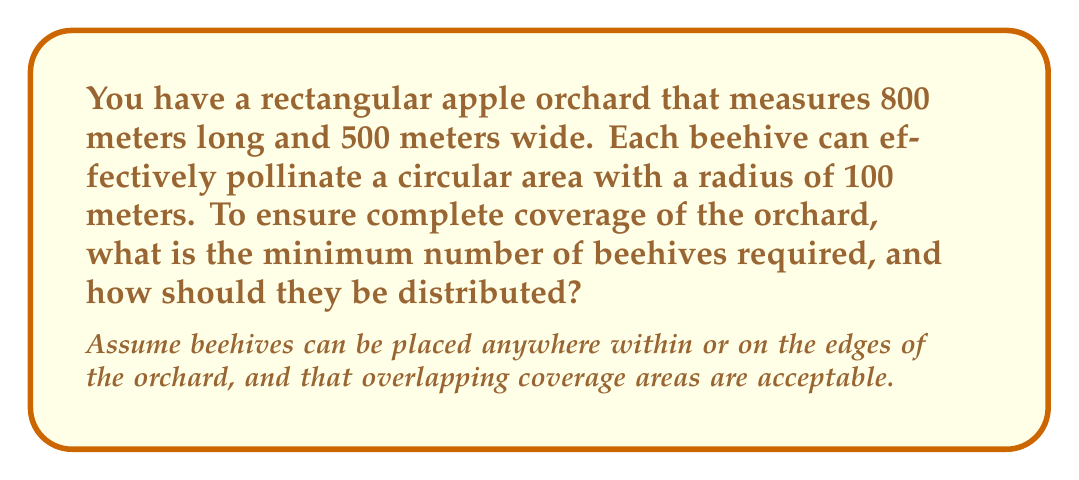Can you answer this question? To solve this problem, we need to follow these steps:

1. Calculate the area of the orchard:
   Area of orchard = $800 \text{ m} \times 500 \text{ m} = 400,000 \text{ m}^2$

2. Calculate the area covered by each beehive:
   Area covered by one beehive = $\pi r^2 = \pi \times (100 \text{ m})^2 = 31,415.93 \text{ m}^2$

3. To ensure complete coverage, we need to arrange the beehives in a grid pattern. Let's determine the spacing between beehives:
   - Horizontal spacing: $\sqrt{3} \times 100 \text{ m} = 173.2 \text{ m}$
   - Vertical spacing: $150 \text{ m}$

   This arrangement creates a hexagonal pattern of coverage, which is the most efficient.

4. Calculate the number of rows and columns:
   - Number of columns = $\lceil 800 \text{ m} / 173.2 \text{ m} \rceil = 5$
   - Number of rows = $\lceil 500 \text{ m} / 150 \text{ m} \rceil = 4$

5. Calculate the total number of beehives:
   - Even rows: 5 beehives
   - Odd rows: 4 beehives
   Total beehives = $(2 \times 5) + (2 \times 4) = 18$

6. Distribution pattern:
   - Place beehives in a staggered grid
   - First row: 5 beehives, starting at (86.6 m, 75 m), spaced 173.2 m apart
   - Second row: 4 beehives, starting at (173.2 m, 225 m), spaced 173.2 m apart
   - Third row: Same as first row, but 300 m from the bottom edge
   - Fourth row: Same as second row, but 375 m from the bottom edge

This arrangement ensures complete coverage of the orchard with minimal overlap.
Answer: The minimum number of beehives required is 18, distributed in a staggered grid pattern with 5 beehives in even rows and 4 beehives in odd rows. 